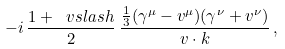Convert formula to latex. <formula><loc_0><loc_0><loc_500><loc_500>- i \, \frac { 1 + \ v s l a s h } { 2 } \, \frac { \frac { 1 } { 3 } ( \gamma ^ { \mu } - v ^ { \mu } ) ( \gamma ^ { \nu } + v ^ { \nu } ) } { v \cdot k } \, ,</formula> 